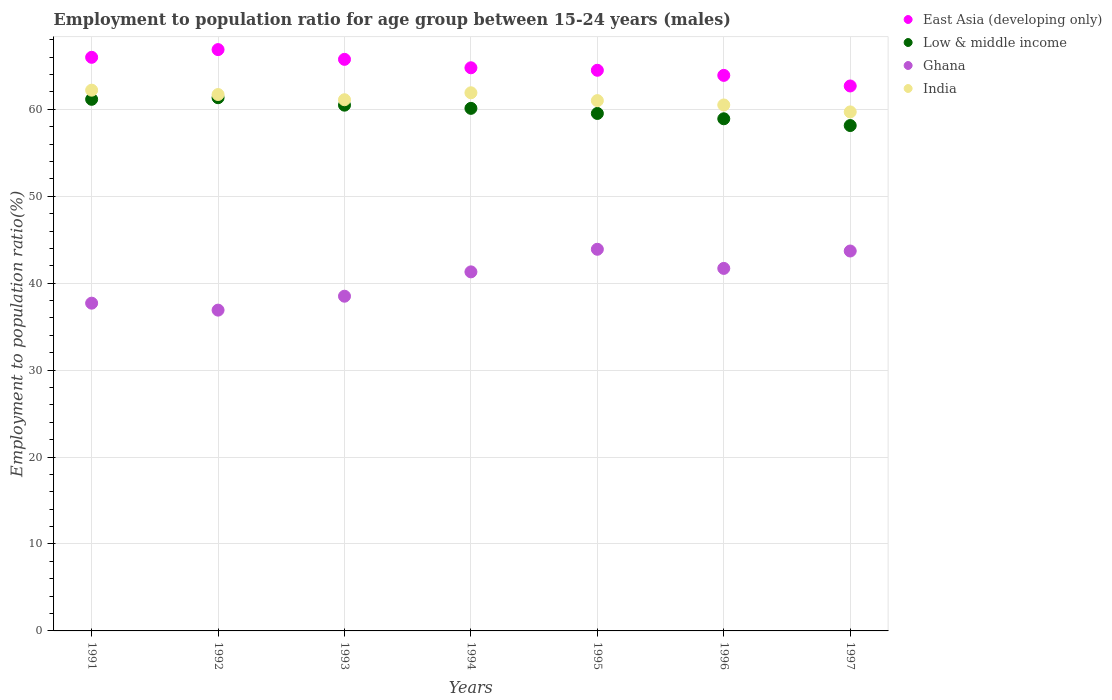Is the number of dotlines equal to the number of legend labels?
Offer a terse response. Yes. What is the employment to population ratio in Low & middle income in 1994?
Provide a short and direct response. 60.11. Across all years, what is the maximum employment to population ratio in Ghana?
Give a very brief answer. 43.9. Across all years, what is the minimum employment to population ratio in Ghana?
Give a very brief answer. 36.9. What is the total employment to population ratio in India in the graph?
Give a very brief answer. 428.1. What is the difference between the employment to population ratio in India in 1992 and that in 1995?
Provide a short and direct response. 0.7. What is the difference between the employment to population ratio in Low & middle income in 1992 and the employment to population ratio in East Asia (developing only) in 1994?
Give a very brief answer. -3.44. What is the average employment to population ratio in East Asia (developing only) per year?
Your response must be concise. 64.92. In the year 1992, what is the difference between the employment to population ratio in Low & middle income and employment to population ratio in Ghana?
Keep it short and to the point. 24.43. What is the ratio of the employment to population ratio in Ghana in 1991 to that in 1996?
Offer a very short reply. 0.9. Is the difference between the employment to population ratio in Low & middle income in 1996 and 1997 greater than the difference between the employment to population ratio in Ghana in 1996 and 1997?
Your answer should be very brief. Yes. What is the difference between the highest and the second highest employment to population ratio in Low & middle income?
Offer a terse response. 0.18. In how many years, is the employment to population ratio in India greater than the average employment to population ratio in India taken over all years?
Provide a succinct answer. 3. Is the sum of the employment to population ratio in Low & middle income in 1995 and 1997 greater than the maximum employment to population ratio in India across all years?
Your answer should be compact. Yes. Is it the case that in every year, the sum of the employment to population ratio in India and employment to population ratio in Ghana  is greater than the sum of employment to population ratio in Low & middle income and employment to population ratio in East Asia (developing only)?
Ensure brevity in your answer.  Yes. Does the employment to population ratio in Low & middle income monotonically increase over the years?
Your response must be concise. No. Is the employment to population ratio in Ghana strictly greater than the employment to population ratio in India over the years?
Your answer should be very brief. No. How many dotlines are there?
Keep it short and to the point. 4. Are the values on the major ticks of Y-axis written in scientific E-notation?
Keep it short and to the point. No. Where does the legend appear in the graph?
Give a very brief answer. Top right. How are the legend labels stacked?
Your response must be concise. Vertical. What is the title of the graph?
Keep it short and to the point. Employment to population ratio for age group between 15-24 years (males). What is the label or title of the X-axis?
Your answer should be compact. Years. What is the Employment to population ratio(%) of East Asia (developing only) in 1991?
Offer a terse response. 65.98. What is the Employment to population ratio(%) of Low & middle income in 1991?
Keep it short and to the point. 61.15. What is the Employment to population ratio(%) in Ghana in 1991?
Keep it short and to the point. 37.7. What is the Employment to population ratio(%) of India in 1991?
Provide a succinct answer. 62.2. What is the Employment to population ratio(%) in East Asia (developing only) in 1992?
Provide a short and direct response. 66.87. What is the Employment to population ratio(%) in Low & middle income in 1992?
Your answer should be compact. 61.33. What is the Employment to population ratio(%) of Ghana in 1992?
Ensure brevity in your answer.  36.9. What is the Employment to population ratio(%) of India in 1992?
Offer a terse response. 61.7. What is the Employment to population ratio(%) of East Asia (developing only) in 1993?
Your answer should be very brief. 65.75. What is the Employment to population ratio(%) of Low & middle income in 1993?
Offer a terse response. 60.48. What is the Employment to population ratio(%) of Ghana in 1993?
Your answer should be very brief. 38.5. What is the Employment to population ratio(%) of India in 1993?
Your response must be concise. 61.1. What is the Employment to population ratio(%) of East Asia (developing only) in 1994?
Make the answer very short. 64.78. What is the Employment to population ratio(%) in Low & middle income in 1994?
Offer a terse response. 60.11. What is the Employment to population ratio(%) of Ghana in 1994?
Your response must be concise. 41.3. What is the Employment to population ratio(%) of India in 1994?
Your response must be concise. 61.9. What is the Employment to population ratio(%) of East Asia (developing only) in 1995?
Make the answer very short. 64.49. What is the Employment to population ratio(%) of Low & middle income in 1995?
Provide a short and direct response. 59.52. What is the Employment to population ratio(%) of Ghana in 1995?
Provide a succinct answer. 43.9. What is the Employment to population ratio(%) in India in 1995?
Give a very brief answer. 61. What is the Employment to population ratio(%) in East Asia (developing only) in 1996?
Provide a short and direct response. 63.9. What is the Employment to population ratio(%) in Low & middle income in 1996?
Your answer should be compact. 58.91. What is the Employment to population ratio(%) of Ghana in 1996?
Provide a succinct answer. 41.7. What is the Employment to population ratio(%) in India in 1996?
Your response must be concise. 60.5. What is the Employment to population ratio(%) of East Asia (developing only) in 1997?
Keep it short and to the point. 62.68. What is the Employment to population ratio(%) in Low & middle income in 1997?
Your answer should be very brief. 58.13. What is the Employment to population ratio(%) in Ghana in 1997?
Keep it short and to the point. 43.7. What is the Employment to population ratio(%) of India in 1997?
Your response must be concise. 59.7. Across all years, what is the maximum Employment to population ratio(%) in East Asia (developing only)?
Provide a short and direct response. 66.87. Across all years, what is the maximum Employment to population ratio(%) of Low & middle income?
Offer a very short reply. 61.33. Across all years, what is the maximum Employment to population ratio(%) in Ghana?
Give a very brief answer. 43.9. Across all years, what is the maximum Employment to population ratio(%) of India?
Your answer should be compact. 62.2. Across all years, what is the minimum Employment to population ratio(%) in East Asia (developing only)?
Ensure brevity in your answer.  62.68. Across all years, what is the minimum Employment to population ratio(%) in Low & middle income?
Offer a very short reply. 58.13. Across all years, what is the minimum Employment to population ratio(%) of Ghana?
Provide a short and direct response. 36.9. Across all years, what is the minimum Employment to population ratio(%) of India?
Provide a short and direct response. 59.7. What is the total Employment to population ratio(%) of East Asia (developing only) in the graph?
Provide a short and direct response. 454.44. What is the total Employment to population ratio(%) of Low & middle income in the graph?
Provide a succinct answer. 419.63. What is the total Employment to population ratio(%) in Ghana in the graph?
Make the answer very short. 283.7. What is the total Employment to population ratio(%) in India in the graph?
Your answer should be compact. 428.1. What is the difference between the Employment to population ratio(%) of East Asia (developing only) in 1991 and that in 1992?
Offer a terse response. -0.89. What is the difference between the Employment to population ratio(%) of Low & middle income in 1991 and that in 1992?
Offer a terse response. -0.18. What is the difference between the Employment to population ratio(%) of Ghana in 1991 and that in 1992?
Give a very brief answer. 0.8. What is the difference between the Employment to population ratio(%) in East Asia (developing only) in 1991 and that in 1993?
Ensure brevity in your answer.  0.23. What is the difference between the Employment to population ratio(%) in Low & middle income in 1991 and that in 1993?
Make the answer very short. 0.67. What is the difference between the Employment to population ratio(%) of Ghana in 1991 and that in 1993?
Your response must be concise. -0.8. What is the difference between the Employment to population ratio(%) in East Asia (developing only) in 1991 and that in 1994?
Your answer should be compact. 1.2. What is the difference between the Employment to population ratio(%) in Low & middle income in 1991 and that in 1994?
Offer a terse response. 1.04. What is the difference between the Employment to population ratio(%) of East Asia (developing only) in 1991 and that in 1995?
Your response must be concise. 1.49. What is the difference between the Employment to population ratio(%) of Low & middle income in 1991 and that in 1995?
Your answer should be very brief. 1.63. What is the difference between the Employment to population ratio(%) of Ghana in 1991 and that in 1995?
Give a very brief answer. -6.2. What is the difference between the Employment to population ratio(%) in East Asia (developing only) in 1991 and that in 1996?
Give a very brief answer. 2.08. What is the difference between the Employment to population ratio(%) in Low & middle income in 1991 and that in 1996?
Offer a very short reply. 2.24. What is the difference between the Employment to population ratio(%) in East Asia (developing only) in 1991 and that in 1997?
Your answer should be very brief. 3.3. What is the difference between the Employment to population ratio(%) of Low & middle income in 1991 and that in 1997?
Your answer should be compact. 3.02. What is the difference between the Employment to population ratio(%) of Ghana in 1991 and that in 1997?
Offer a terse response. -6. What is the difference between the Employment to population ratio(%) of East Asia (developing only) in 1992 and that in 1993?
Give a very brief answer. 1.12. What is the difference between the Employment to population ratio(%) of Low & middle income in 1992 and that in 1993?
Offer a very short reply. 0.86. What is the difference between the Employment to population ratio(%) of Ghana in 1992 and that in 1993?
Make the answer very short. -1.6. What is the difference between the Employment to population ratio(%) of East Asia (developing only) in 1992 and that in 1994?
Your answer should be compact. 2.09. What is the difference between the Employment to population ratio(%) of Low & middle income in 1992 and that in 1994?
Offer a very short reply. 1.22. What is the difference between the Employment to population ratio(%) in India in 1992 and that in 1994?
Keep it short and to the point. -0.2. What is the difference between the Employment to population ratio(%) in East Asia (developing only) in 1992 and that in 1995?
Make the answer very short. 2.38. What is the difference between the Employment to population ratio(%) of Low & middle income in 1992 and that in 1995?
Your answer should be very brief. 1.81. What is the difference between the Employment to population ratio(%) of Ghana in 1992 and that in 1995?
Make the answer very short. -7. What is the difference between the Employment to population ratio(%) of East Asia (developing only) in 1992 and that in 1996?
Give a very brief answer. 2.97. What is the difference between the Employment to population ratio(%) in Low & middle income in 1992 and that in 1996?
Provide a short and direct response. 2.42. What is the difference between the Employment to population ratio(%) of Ghana in 1992 and that in 1996?
Provide a short and direct response. -4.8. What is the difference between the Employment to population ratio(%) in East Asia (developing only) in 1992 and that in 1997?
Your response must be concise. 4.18. What is the difference between the Employment to population ratio(%) of Low & middle income in 1992 and that in 1997?
Offer a terse response. 3.2. What is the difference between the Employment to population ratio(%) in Ghana in 1992 and that in 1997?
Provide a succinct answer. -6.8. What is the difference between the Employment to population ratio(%) of India in 1992 and that in 1997?
Provide a succinct answer. 2. What is the difference between the Employment to population ratio(%) of East Asia (developing only) in 1993 and that in 1994?
Ensure brevity in your answer.  0.97. What is the difference between the Employment to population ratio(%) in Low & middle income in 1993 and that in 1994?
Your answer should be compact. 0.37. What is the difference between the Employment to population ratio(%) of Ghana in 1993 and that in 1994?
Keep it short and to the point. -2.8. What is the difference between the Employment to population ratio(%) of East Asia (developing only) in 1993 and that in 1995?
Keep it short and to the point. 1.26. What is the difference between the Employment to population ratio(%) in Low & middle income in 1993 and that in 1995?
Your answer should be very brief. 0.95. What is the difference between the Employment to population ratio(%) of East Asia (developing only) in 1993 and that in 1996?
Offer a terse response. 1.84. What is the difference between the Employment to population ratio(%) of Low & middle income in 1993 and that in 1996?
Provide a succinct answer. 1.56. What is the difference between the Employment to population ratio(%) of Ghana in 1993 and that in 1996?
Keep it short and to the point. -3.2. What is the difference between the Employment to population ratio(%) in East Asia (developing only) in 1993 and that in 1997?
Provide a short and direct response. 3.06. What is the difference between the Employment to population ratio(%) in Low & middle income in 1993 and that in 1997?
Your response must be concise. 2.34. What is the difference between the Employment to population ratio(%) in Ghana in 1993 and that in 1997?
Ensure brevity in your answer.  -5.2. What is the difference between the Employment to population ratio(%) of East Asia (developing only) in 1994 and that in 1995?
Your response must be concise. 0.29. What is the difference between the Employment to population ratio(%) of Low & middle income in 1994 and that in 1995?
Your answer should be compact. 0.59. What is the difference between the Employment to population ratio(%) of Ghana in 1994 and that in 1995?
Give a very brief answer. -2.6. What is the difference between the Employment to population ratio(%) of India in 1994 and that in 1995?
Your answer should be compact. 0.9. What is the difference between the Employment to population ratio(%) of East Asia (developing only) in 1994 and that in 1996?
Your answer should be compact. 0.87. What is the difference between the Employment to population ratio(%) of Low & middle income in 1994 and that in 1996?
Keep it short and to the point. 1.2. What is the difference between the Employment to population ratio(%) of Ghana in 1994 and that in 1996?
Ensure brevity in your answer.  -0.4. What is the difference between the Employment to population ratio(%) in East Asia (developing only) in 1994 and that in 1997?
Your answer should be compact. 2.09. What is the difference between the Employment to population ratio(%) in Low & middle income in 1994 and that in 1997?
Your answer should be compact. 1.98. What is the difference between the Employment to population ratio(%) in Ghana in 1994 and that in 1997?
Your answer should be compact. -2.4. What is the difference between the Employment to population ratio(%) in India in 1994 and that in 1997?
Keep it short and to the point. 2.2. What is the difference between the Employment to population ratio(%) in East Asia (developing only) in 1995 and that in 1996?
Your answer should be very brief. 0.59. What is the difference between the Employment to population ratio(%) in Low & middle income in 1995 and that in 1996?
Your answer should be very brief. 0.61. What is the difference between the Employment to population ratio(%) in India in 1995 and that in 1996?
Offer a very short reply. 0.5. What is the difference between the Employment to population ratio(%) in East Asia (developing only) in 1995 and that in 1997?
Your answer should be compact. 1.81. What is the difference between the Employment to population ratio(%) of Low & middle income in 1995 and that in 1997?
Your answer should be compact. 1.39. What is the difference between the Employment to population ratio(%) of Ghana in 1995 and that in 1997?
Keep it short and to the point. 0.2. What is the difference between the Employment to population ratio(%) of East Asia (developing only) in 1996 and that in 1997?
Offer a terse response. 1.22. What is the difference between the Employment to population ratio(%) in Low & middle income in 1996 and that in 1997?
Your answer should be very brief. 0.78. What is the difference between the Employment to population ratio(%) in Ghana in 1996 and that in 1997?
Offer a terse response. -2. What is the difference between the Employment to population ratio(%) of East Asia (developing only) in 1991 and the Employment to population ratio(%) of Low & middle income in 1992?
Provide a short and direct response. 4.65. What is the difference between the Employment to population ratio(%) of East Asia (developing only) in 1991 and the Employment to population ratio(%) of Ghana in 1992?
Your response must be concise. 29.08. What is the difference between the Employment to population ratio(%) in East Asia (developing only) in 1991 and the Employment to population ratio(%) in India in 1992?
Your answer should be compact. 4.28. What is the difference between the Employment to population ratio(%) of Low & middle income in 1991 and the Employment to population ratio(%) of Ghana in 1992?
Your answer should be very brief. 24.25. What is the difference between the Employment to population ratio(%) in Low & middle income in 1991 and the Employment to population ratio(%) in India in 1992?
Make the answer very short. -0.55. What is the difference between the Employment to population ratio(%) of East Asia (developing only) in 1991 and the Employment to population ratio(%) of Low & middle income in 1993?
Your response must be concise. 5.5. What is the difference between the Employment to population ratio(%) of East Asia (developing only) in 1991 and the Employment to population ratio(%) of Ghana in 1993?
Provide a short and direct response. 27.48. What is the difference between the Employment to population ratio(%) of East Asia (developing only) in 1991 and the Employment to population ratio(%) of India in 1993?
Ensure brevity in your answer.  4.88. What is the difference between the Employment to population ratio(%) in Low & middle income in 1991 and the Employment to population ratio(%) in Ghana in 1993?
Provide a short and direct response. 22.65. What is the difference between the Employment to population ratio(%) of Low & middle income in 1991 and the Employment to population ratio(%) of India in 1993?
Your answer should be compact. 0.05. What is the difference between the Employment to population ratio(%) of Ghana in 1991 and the Employment to population ratio(%) of India in 1993?
Offer a terse response. -23.4. What is the difference between the Employment to population ratio(%) of East Asia (developing only) in 1991 and the Employment to population ratio(%) of Low & middle income in 1994?
Provide a succinct answer. 5.87. What is the difference between the Employment to population ratio(%) in East Asia (developing only) in 1991 and the Employment to population ratio(%) in Ghana in 1994?
Provide a short and direct response. 24.68. What is the difference between the Employment to population ratio(%) of East Asia (developing only) in 1991 and the Employment to population ratio(%) of India in 1994?
Keep it short and to the point. 4.08. What is the difference between the Employment to population ratio(%) in Low & middle income in 1991 and the Employment to population ratio(%) in Ghana in 1994?
Your answer should be compact. 19.85. What is the difference between the Employment to population ratio(%) of Low & middle income in 1991 and the Employment to population ratio(%) of India in 1994?
Your response must be concise. -0.75. What is the difference between the Employment to population ratio(%) in Ghana in 1991 and the Employment to population ratio(%) in India in 1994?
Provide a short and direct response. -24.2. What is the difference between the Employment to population ratio(%) in East Asia (developing only) in 1991 and the Employment to population ratio(%) in Low & middle income in 1995?
Your answer should be very brief. 6.46. What is the difference between the Employment to population ratio(%) of East Asia (developing only) in 1991 and the Employment to population ratio(%) of Ghana in 1995?
Your answer should be very brief. 22.08. What is the difference between the Employment to population ratio(%) in East Asia (developing only) in 1991 and the Employment to population ratio(%) in India in 1995?
Provide a short and direct response. 4.98. What is the difference between the Employment to population ratio(%) in Low & middle income in 1991 and the Employment to population ratio(%) in Ghana in 1995?
Your response must be concise. 17.25. What is the difference between the Employment to population ratio(%) in Low & middle income in 1991 and the Employment to population ratio(%) in India in 1995?
Offer a terse response. 0.15. What is the difference between the Employment to population ratio(%) of Ghana in 1991 and the Employment to population ratio(%) of India in 1995?
Provide a short and direct response. -23.3. What is the difference between the Employment to population ratio(%) of East Asia (developing only) in 1991 and the Employment to population ratio(%) of Low & middle income in 1996?
Your response must be concise. 7.07. What is the difference between the Employment to population ratio(%) of East Asia (developing only) in 1991 and the Employment to population ratio(%) of Ghana in 1996?
Your answer should be compact. 24.28. What is the difference between the Employment to population ratio(%) of East Asia (developing only) in 1991 and the Employment to population ratio(%) of India in 1996?
Your response must be concise. 5.48. What is the difference between the Employment to population ratio(%) of Low & middle income in 1991 and the Employment to population ratio(%) of Ghana in 1996?
Ensure brevity in your answer.  19.45. What is the difference between the Employment to population ratio(%) in Low & middle income in 1991 and the Employment to population ratio(%) in India in 1996?
Offer a terse response. 0.65. What is the difference between the Employment to population ratio(%) of Ghana in 1991 and the Employment to population ratio(%) of India in 1996?
Ensure brevity in your answer.  -22.8. What is the difference between the Employment to population ratio(%) of East Asia (developing only) in 1991 and the Employment to population ratio(%) of Low & middle income in 1997?
Offer a terse response. 7.85. What is the difference between the Employment to population ratio(%) of East Asia (developing only) in 1991 and the Employment to population ratio(%) of Ghana in 1997?
Provide a short and direct response. 22.28. What is the difference between the Employment to population ratio(%) of East Asia (developing only) in 1991 and the Employment to population ratio(%) of India in 1997?
Ensure brevity in your answer.  6.28. What is the difference between the Employment to population ratio(%) in Low & middle income in 1991 and the Employment to population ratio(%) in Ghana in 1997?
Your answer should be compact. 17.45. What is the difference between the Employment to population ratio(%) in Low & middle income in 1991 and the Employment to population ratio(%) in India in 1997?
Your answer should be compact. 1.45. What is the difference between the Employment to population ratio(%) of Ghana in 1991 and the Employment to population ratio(%) of India in 1997?
Your answer should be compact. -22. What is the difference between the Employment to population ratio(%) of East Asia (developing only) in 1992 and the Employment to population ratio(%) of Low & middle income in 1993?
Make the answer very short. 6.39. What is the difference between the Employment to population ratio(%) in East Asia (developing only) in 1992 and the Employment to population ratio(%) in Ghana in 1993?
Keep it short and to the point. 28.37. What is the difference between the Employment to population ratio(%) in East Asia (developing only) in 1992 and the Employment to population ratio(%) in India in 1993?
Provide a short and direct response. 5.77. What is the difference between the Employment to population ratio(%) of Low & middle income in 1992 and the Employment to population ratio(%) of Ghana in 1993?
Your answer should be very brief. 22.83. What is the difference between the Employment to population ratio(%) in Low & middle income in 1992 and the Employment to population ratio(%) in India in 1993?
Offer a terse response. 0.23. What is the difference between the Employment to population ratio(%) in Ghana in 1992 and the Employment to population ratio(%) in India in 1993?
Keep it short and to the point. -24.2. What is the difference between the Employment to population ratio(%) in East Asia (developing only) in 1992 and the Employment to population ratio(%) in Low & middle income in 1994?
Ensure brevity in your answer.  6.76. What is the difference between the Employment to population ratio(%) in East Asia (developing only) in 1992 and the Employment to population ratio(%) in Ghana in 1994?
Provide a succinct answer. 25.57. What is the difference between the Employment to population ratio(%) of East Asia (developing only) in 1992 and the Employment to population ratio(%) of India in 1994?
Offer a terse response. 4.97. What is the difference between the Employment to population ratio(%) of Low & middle income in 1992 and the Employment to population ratio(%) of Ghana in 1994?
Ensure brevity in your answer.  20.03. What is the difference between the Employment to population ratio(%) of Low & middle income in 1992 and the Employment to population ratio(%) of India in 1994?
Offer a very short reply. -0.57. What is the difference between the Employment to population ratio(%) of East Asia (developing only) in 1992 and the Employment to population ratio(%) of Low & middle income in 1995?
Provide a succinct answer. 7.34. What is the difference between the Employment to population ratio(%) of East Asia (developing only) in 1992 and the Employment to population ratio(%) of Ghana in 1995?
Your answer should be compact. 22.97. What is the difference between the Employment to population ratio(%) in East Asia (developing only) in 1992 and the Employment to population ratio(%) in India in 1995?
Ensure brevity in your answer.  5.87. What is the difference between the Employment to population ratio(%) of Low & middle income in 1992 and the Employment to population ratio(%) of Ghana in 1995?
Keep it short and to the point. 17.43. What is the difference between the Employment to population ratio(%) in Low & middle income in 1992 and the Employment to population ratio(%) in India in 1995?
Your response must be concise. 0.33. What is the difference between the Employment to population ratio(%) in Ghana in 1992 and the Employment to population ratio(%) in India in 1995?
Keep it short and to the point. -24.1. What is the difference between the Employment to population ratio(%) in East Asia (developing only) in 1992 and the Employment to population ratio(%) in Low & middle income in 1996?
Keep it short and to the point. 7.96. What is the difference between the Employment to population ratio(%) in East Asia (developing only) in 1992 and the Employment to population ratio(%) in Ghana in 1996?
Make the answer very short. 25.17. What is the difference between the Employment to population ratio(%) in East Asia (developing only) in 1992 and the Employment to population ratio(%) in India in 1996?
Ensure brevity in your answer.  6.37. What is the difference between the Employment to population ratio(%) in Low & middle income in 1992 and the Employment to population ratio(%) in Ghana in 1996?
Your answer should be very brief. 19.63. What is the difference between the Employment to population ratio(%) in Low & middle income in 1992 and the Employment to population ratio(%) in India in 1996?
Your answer should be very brief. 0.83. What is the difference between the Employment to population ratio(%) in Ghana in 1992 and the Employment to population ratio(%) in India in 1996?
Offer a very short reply. -23.6. What is the difference between the Employment to population ratio(%) in East Asia (developing only) in 1992 and the Employment to population ratio(%) in Low & middle income in 1997?
Offer a very short reply. 8.74. What is the difference between the Employment to population ratio(%) of East Asia (developing only) in 1992 and the Employment to population ratio(%) of Ghana in 1997?
Ensure brevity in your answer.  23.17. What is the difference between the Employment to population ratio(%) of East Asia (developing only) in 1992 and the Employment to population ratio(%) of India in 1997?
Your answer should be very brief. 7.17. What is the difference between the Employment to population ratio(%) in Low & middle income in 1992 and the Employment to population ratio(%) in Ghana in 1997?
Make the answer very short. 17.63. What is the difference between the Employment to population ratio(%) of Low & middle income in 1992 and the Employment to population ratio(%) of India in 1997?
Give a very brief answer. 1.63. What is the difference between the Employment to population ratio(%) in Ghana in 1992 and the Employment to population ratio(%) in India in 1997?
Your answer should be compact. -22.8. What is the difference between the Employment to population ratio(%) of East Asia (developing only) in 1993 and the Employment to population ratio(%) of Low & middle income in 1994?
Offer a terse response. 5.64. What is the difference between the Employment to population ratio(%) in East Asia (developing only) in 1993 and the Employment to population ratio(%) in Ghana in 1994?
Your response must be concise. 24.45. What is the difference between the Employment to population ratio(%) of East Asia (developing only) in 1993 and the Employment to population ratio(%) of India in 1994?
Give a very brief answer. 3.85. What is the difference between the Employment to population ratio(%) of Low & middle income in 1993 and the Employment to population ratio(%) of Ghana in 1994?
Make the answer very short. 19.18. What is the difference between the Employment to population ratio(%) of Low & middle income in 1993 and the Employment to population ratio(%) of India in 1994?
Provide a short and direct response. -1.42. What is the difference between the Employment to population ratio(%) of Ghana in 1993 and the Employment to population ratio(%) of India in 1994?
Your response must be concise. -23.4. What is the difference between the Employment to population ratio(%) of East Asia (developing only) in 1993 and the Employment to population ratio(%) of Low & middle income in 1995?
Keep it short and to the point. 6.22. What is the difference between the Employment to population ratio(%) in East Asia (developing only) in 1993 and the Employment to population ratio(%) in Ghana in 1995?
Provide a succinct answer. 21.85. What is the difference between the Employment to population ratio(%) in East Asia (developing only) in 1993 and the Employment to population ratio(%) in India in 1995?
Offer a very short reply. 4.75. What is the difference between the Employment to population ratio(%) of Low & middle income in 1993 and the Employment to population ratio(%) of Ghana in 1995?
Make the answer very short. 16.58. What is the difference between the Employment to population ratio(%) of Low & middle income in 1993 and the Employment to population ratio(%) of India in 1995?
Offer a very short reply. -0.52. What is the difference between the Employment to population ratio(%) of Ghana in 1993 and the Employment to population ratio(%) of India in 1995?
Provide a short and direct response. -22.5. What is the difference between the Employment to population ratio(%) of East Asia (developing only) in 1993 and the Employment to population ratio(%) of Low & middle income in 1996?
Provide a short and direct response. 6.84. What is the difference between the Employment to population ratio(%) of East Asia (developing only) in 1993 and the Employment to population ratio(%) of Ghana in 1996?
Your answer should be very brief. 24.05. What is the difference between the Employment to population ratio(%) of East Asia (developing only) in 1993 and the Employment to population ratio(%) of India in 1996?
Give a very brief answer. 5.25. What is the difference between the Employment to population ratio(%) in Low & middle income in 1993 and the Employment to population ratio(%) in Ghana in 1996?
Keep it short and to the point. 18.78. What is the difference between the Employment to population ratio(%) of Low & middle income in 1993 and the Employment to population ratio(%) of India in 1996?
Offer a very short reply. -0.02. What is the difference between the Employment to population ratio(%) in Ghana in 1993 and the Employment to population ratio(%) in India in 1996?
Provide a succinct answer. -22. What is the difference between the Employment to population ratio(%) of East Asia (developing only) in 1993 and the Employment to population ratio(%) of Low & middle income in 1997?
Provide a short and direct response. 7.61. What is the difference between the Employment to population ratio(%) in East Asia (developing only) in 1993 and the Employment to population ratio(%) in Ghana in 1997?
Make the answer very short. 22.05. What is the difference between the Employment to population ratio(%) of East Asia (developing only) in 1993 and the Employment to population ratio(%) of India in 1997?
Ensure brevity in your answer.  6.05. What is the difference between the Employment to population ratio(%) in Low & middle income in 1993 and the Employment to population ratio(%) in Ghana in 1997?
Make the answer very short. 16.78. What is the difference between the Employment to population ratio(%) in Low & middle income in 1993 and the Employment to population ratio(%) in India in 1997?
Your response must be concise. 0.78. What is the difference between the Employment to population ratio(%) of Ghana in 1993 and the Employment to population ratio(%) of India in 1997?
Ensure brevity in your answer.  -21.2. What is the difference between the Employment to population ratio(%) of East Asia (developing only) in 1994 and the Employment to population ratio(%) of Low & middle income in 1995?
Provide a succinct answer. 5.25. What is the difference between the Employment to population ratio(%) of East Asia (developing only) in 1994 and the Employment to population ratio(%) of Ghana in 1995?
Make the answer very short. 20.88. What is the difference between the Employment to population ratio(%) in East Asia (developing only) in 1994 and the Employment to population ratio(%) in India in 1995?
Make the answer very short. 3.78. What is the difference between the Employment to population ratio(%) of Low & middle income in 1994 and the Employment to population ratio(%) of Ghana in 1995?
Your answer should be very brief. 16.21. What is the difference between the Employment to population ratio(%) of Low & middle income in 1994 and the Employment to population ratio(%) of India in 1995?
Your answer should be compact. -0.89. What is the difference between the Employment to population ratio(%) in Ghana in 1994 and the Employment to population ratio(%) in India in 1995?
Offer a very short reply. -19.7. What is the difference between the Employment to population ratio(%) of East Asia (developing only) in 1994 and the Employment to population ratio(%) of Low & middle income in 1996?
Ensure brevity in your answer.  5.87. What is the difference between the Employment to population ratio(%) of East Asia (developing only) in 1994 and the Employment to population ratio(%) of Ghana in 1996?
Offer a very short reply. 23.08. What is the difference between the Employment to population ratio(%) in East Asia (developing only) in 1994 and the Employment to population ratio(%) in India in 1996?
Ensure brevity in your answer.  4.28. What is the difference between the Employment to population ratio(%) in Low & middle income in 1994 and the Employment to population ratio(%) in Ghana in 1996?
Your response must be concise. 18.41. What is the difference between the Employment to population ratio(%) of Low & middle income in 1994 and the Employment to population ratio(%) of India in 1996?
Offer a terse response. -0.39. What is the difference between the Employment to population ratio(%) in Ghana in 1994 and the Employment to population ratio(%) in India in 1996?
Give a very brief answer. -19.2. What is the difference between the Employment to population ratio(%) in East Asia (developing only) in 1994 and the Employment to population ratio(%) in Low & middle income in 1997?
Ensure brevity in your answer.  6.64. What is the difference between the Employment to population ratio(%) of East Asia (developing only) in 1994 and the Employment to population ratio(%) of Ghana in 1997?
Provide a succinct answer. 21.08. What is the difference between the Employment to population ratio(%) of East Asia (developing only) in 1994 and the Employment to population ratio(%) of India in 1997?
Your answer should be very brief. 5.08. What is the difference between the Employment to population ratio(%) of Low & middle income in 1994 and the Employment to population ratio(%) of Ghana in 1997?
Your answer should be compact. 16.41. What is the difference between the Employment to population ratio(%) of Low & middle income in 1994 and the Employment to population ratio(%) of India in 1997?
Provide a succinct answer. 0.41. What is the difference between the Employment to population ratio(%) of Ghana in 1994 and the Employment to population ratio(%) of India in 1997?
Your response must be concise. -18.4. What is the difference between the Employment to population ratio(%) in East Asia (developing only) in 1995 and the Employment to population ratio(%) in Low & middle income in 1996?
Your answer should be compact. 5.58. What is the difference between the Employment to population ratio(%) of East Asia (developing only) in 1995 and the Employment to population ratio(%) of Ghana in 1996?
Ensure brevity in your answer.  22.79. What is the difference between the Employment to population ratio(%) of East Asia (developing only) in 1995 and the Employment to population ratio(%) of India in 1996?
Offer a terse response. 3.99. What is the difference between the Employment to population ratio(%) in Low & middle income in 1995 and the Employment to population ratio(%) in Ghana in 1996?
Make the answer very short. 17.82. What is the difference between the Employment to population ratio(%) in Low & middle income in 1995 and the Employment to population ratio(%) in India in 1996?
Your answer should be very brief. -0.98. What is the difference between the Employment to population ratio(%) in Ghana in 1995 and the Employment to population ratio(%) in India in 1996?
Provide a succinct answer. -16.6. What is the difference between the Employment to population ratio(%) in East Asia (developing only) in 1995 and the Employment to population ratio(%) in Low & middle income in 1997?
Provide a short and direct response. 6.36. What is the difference between the Employment to population ratio(%) of East Asia (developing only) in 1995 and the Employment to population ratio(%) of Ghana in 1997?
Offer a terse response. 20.79. What is the difference between the Employment to population ratio(%) of East Asia (developing only) in 1995 and the Employment to population ratio(%) of India in 1997?
Ensure brevity in your answer.  4.79. What is the difference between the Employment to population ratio(%) in Low & middle income in 1995 and the Employment to population ratio(%) in Ghana in 1997?
Provide a succinct answer. 15.82. What is the difference between the Employment to population ratio(%) in Low & middle income in 1995 and the Employment to population ratio(%) in India in 1997?
Your answer should be compact. -0.18. What is the difference between the Employment to population ratio(%) of Ghana in 1995 and the Employment to population ratio(%) of India in 1997?
Your answer should be very brief. -15.8. What is the difference between the Employment to population ratio(%) in East Asia (developing only) in 1996 and the Employment to population ratio(%) in Low & middle income in 1997?
Keep it short and to the point. 5.77. What is the difference between the Employment to population ratio(%) in East Asia (developing only) in 1996 and the Employment to population ratio(%) in Ghana in 1997?
Keep it short and to the point. 20.2. What is the difference between the Employment to population ratio(%) in East Asia (developing only) in 1996 and the Employment to population ratio(%) in India in 1997?
Provide a short and direct response. 4.2. What is the difference between the Employment to population ratio(%) in Low & middle income in 1996 and the Employment to population ratio(%) in Ghana in 1997?
Keep it short and to the point. 15.21. What is the difference between the Employment to population ratio(%) in Low & middle income in 1996 and the Employment to population ratio(%) in India in 1997?
Keep it short and to the point. -0.79. What is the average Employment to population ratio(%) in East Asia (developing only) per year?
Keep it short and to the point. 64.92. What is the average Employment to population ratio(%) in Low & middle income per year?
Your response must be concise. 59.95. What is the average Employment to population ratio(%) of Ghana per year?
Ensure brevity in your answer.  40.53. What is the average Employment to population ratio(%) in India per year?
Keep it short and to the point. 61.16. In the year 1991, what is the difference between the Employment to population ratio(%) in East Asia (developing only) and Employment to population ratio(%) in Low & middle income?
Provide a short and direct response. 4.83. In the year 1991, what is the difference between the Employment to population ratio(%) in East Asia (developing only) and Employment to population ratio(%) in Ghana?
Make the answer very short. 28.28. In the year 1991, what is the difference between the Employment to population ratio(%) in East Asia (developing only) and Employment to population ratio(%) in India?
Offer a very short reply. 3.78. In the year 1991, what is the difference between the Employment to population ratio(%) in Low & middle income and Employment to population ratio(%) in Ghana?
Offer a terse response. 23.45. In the year 1991, what is the difference between the Employment to population ratio(%) of Low & middle income and Employment to population ratio(%) of India?
Your answer should be compact. -1.05. In the year 1991, what is the difference between the Employment to population ratio(%) of Ghana and Employment to population ratio(%) of India?
Your answer should be very brief. -24.5. In the year 1992, what is the difference between the Employment to population ratio(%) in East Asia (developing only) and Employment to population ratio(%) in Low & middle income?
Offer a very short reply. 5.53. In the year 1992, what is the difference between the Employment to population ratio(%) in East Asia (developing only) and Employment to population ratio(%) in Ghana?
Ensure brevity in your answer.  29.97. In the year 1992, what is the difference between the Employment to population ratio(%) in East Asia (developing only) and Employment to population ratio(%) in India?
Give a very brief answer. 5.17. In the year 1992, what is the difference between the Employment to population ratio(%) in Low & middle income and Employment to population ratio(%) in Ghana?
Your answer should be compact. 24.43. In the year 1992, what is the difference between the Employment to population ratio(%) in Low & middle income and Employment to population ratio(%) in India?
Offer a very short reply. -0.37. In the year 1992, what is the difference between the Employment to population ratio(%) in Ghana and Employment to population ratio(%) in India?
Provide a succinct answer. -24.8. In the year 1993, what is the difference between the Employment to population ratio(%) in East Asia (developing only) and Employment to population ratio(%) in Low & middle income?
Offer a terse response. 5.27. In the year 1993, what is the difference between the Employment to population ratio(%) in East Asia (developing only) and Employment to population ratio(%) in Ghana?
Provide a short and direct response. 27.25. In the year 1993, what is the difference between the Employment to population ratio(%) of East Asia (developing only) and Employment to population ratio(%) of India?
Your response must be concise. 4.65. In the year 1993, what is the difference between the Employment to population ratio(%) of Low & middle income and Employment to population ratio(%) of Ghana?
Provide a succinct answer. 21.98. In the year 1993, what is the difference between the Employment to population ratio(%) in Low & middle income and Employment to population ratio(%) in India?
Your answer should be compact. -0.62. In the year 1993, what is the difference between the Employment to population ratio(%) of Ghana and Employment to population ratio(%) of India?
Make the answer very short. -22.6. In the year 1994, what is the difference between the Employment to population ratio(%) of East Asia (developing only) and Employment to population ratio(%) of Low & middle income?
Ensure brevity in your answer.  4.67. In the year 1994, what is the difference between the Employment to population ratio(%) of East Asia (developing only) and Employment to population ratio(%) of Ghana?
Your answer should be very brief. 23.48. In the year 1994, what is the difference between the Employment to population ratio(%) in East Asia (developing only) and Employment to population ratio(%) in India?
Offer a terse response. 2.88. In the year 1994, what is the difference between the Employment to population ratio(%) in Low & middle income and Employment to population ratio(%) in Ghana?
Your answer should be very brief. 18.81. In the year 1994, what is the difference between the Employment to population ratio(%) of Low & middle income and Employment to population ratio(%) of India?
Give a very brief answer. -1.79. In the year 1994, what is the difference between the Employment to population ratio(%) of Ghana and Employment to population ratio(%) of India?
Keep it short and to the point. -20.6. In the year 1995, what is the difference between the Employment to population ratio(%) of East Asia (developing only) and Employment to population ratio(%) of Low & middle income?
Offer a very short reply. 4.97. In the year 1995, what is the difference between the Employment to population ratio(%) of East Asia (developing only) and Employment to population ratio(%) of Ghana?
Give a very brief answer. 20.59. In the year 1995, what is the difference between the Employment to population ratio(%) of East Asia (developing only) and Employment to population ratio(%) of India?
Your answer should be compact. 3.49. In the year 1995, what is the difference between the Employment to population ratio(%) of Low & middle income and Employment to population ratio(%) of Ghana?
Give a very brief answer. 15.62. In the year 1995, what is the difference between the Employment to population ratio(%) of Low & middle income and Employment to population ratio(%) of India?
Give a very brief answer. -1.48. In the year 1995, what is the difference between the Employment to population ratio(%) of Ghana and Employment to population ratio(%) of India?
Ensure brevity in your answer.  -17.1. In the year 1996, what is the difference between the Employment to population ratio(%) of East Asia (developing only) and Employment to population ratio(%) of Low & middle income?
Your answer should be very brief. 4.99. In the year 1996, what is the difference between the Employment to population ratio(%) of East Asia (developing only) and Employment to population ratio(%) of Ghana?
Your answer should be compact. 22.2. In the year 1996, what is the difference between the Employment to population ratio(%) in East Asia (developing only) and Employment to population ratio(%) in India?
Give a very brief answer. 3.4. In the year 1996, what is the difference between the Employment to population ratio(%) in Low & middle income and Employment to population ratio(%) in Ghana?
Your answer should be compact. 17.21. In the year 1996, what is the difference between the Employment to population ratio(%) of Low & middle income and Employment to population ratio(%) of India?
Offer a very short reply. -1.59. In the year 1996, what is the difference between the Employment to population ratio(%) of Ghana and Employment to population ratio(%) of India?
Provide a succinct answer. -18.8. In the year 1997, what is the difference between the Employment to population ratio(%) of East Asia (developing only) and Employment to population ratio(%) of Low & middle income?
Your answer should be compact. 4.55. In the year 1997, what is the difference between the Employment to population ratio(%) in East Asia (developing only) and Employment to population ratio(%) in Ghana?
Keep it short and to the point. 18.98. In the year 1997, what is the difference between the Employment to population ratio(%) in East Asia (developing only) and Employment to population ratio(%) in India?
Offer a very short reply. 2.98. In the year 1997, what is the difference between the Employment to population ratio(%) of Low & middle income and Employment to population ratio(%) of Ghana?
Keep it short and to the point. 14.43. In the year 1997, what is the difference between the Employment to population ratio(%) of Low & middle income and Employment to population ratio(%) of India?
Offer a very short reply. -1.57. In the year 1997, what is the difference between the Employment to population ratio(%) of Ghana and Employment to population ratio(%) of India?
Offer a terse response. -16. What is the ratio of the Employment to population ratio(%) of East Asia (developing only) in 1991 to that in 1992?
Give a very brief answer. 0.99. What is the ratio of the Employment to population ratio(%) of Ghana in 1991 to that in 1992?
Offer a terse response. 1.02. What is the ratio of the Employment to population ratio(%) in India in 1991 to that in 1992?
Your answer should be very brief. 1.01. What is the ratio of the Employment to population ratio(%) of Low & middle income in 1991 to that in 1993?
Your answer should be very brief. 1.01. What is the ratio of the Employment to population ratio(%) in Ghana in 1991 to that in 1993?
Offer a terse response. 0.98. What is the ratio of the Employment to population ratio(%) of India in 1991 to that in 1993?
Provide a succinct answer. 1.02. What is the ratio of the Employment to population ratio(%) in East Asia (developing only) in 1991 to that in 1994?
Ensure brevity in your answer.  1.02. What is the ratio of the Employment to population ratio(%) of Low & middle income in 1991 to that in 1994?
Make the answer very short. 1.02. What is the ratio of the Employment to population ratio(%) in Ghana in 1991 to that in 1994?
Your answer should be compact. 0.91. What is the ratio of the Employment to population ratio(%) of India in 1991 to that in 1994?
Your answer should be very brief. 1. What is the ratio of the Employment to population ratio(%) in East Asia (developing only) in 1991 to that in 1995?
Your answer should be compact. 1.02. What is the ratio of the Employment to population ratio(%) in Low & middle income in 1991 to that in 1995?
Your answer should be compact. 1.03. What is the ratio of the Employment to population ratio(%) in Ghana in 1991 to that in 1995?
Offer a terse response. 0.86. What is the ratio of the Employment to population ratio(%) of India in 1991 to that in 1995?
Ensure brevity in your answer.  1.02. What is the ratio of the Employment to population ratio(%) in East Asia (developing only) in 1991 to that in 1996?
Make the answer very short. 1.03. What is the ratio of the Employment to population ratio(%) in Low & middle income in 1991 to that in 1996?
Ensure brevity in your answer.  1.04. What is the ratio of the Employment to population ratio(%) of Ghana in 1991 to that in 1996?
Make the answer very short. 0.9. What is the ratio of the Employment to population ratio(%) in India in 1991 to that in 1996?
Your answer should be very brief. 1.03. What is the ratio of the Employment to population ratio(%) in East Asia (developing only) in 1991 to that in 1997?
Keep it short and to the point. 1.05. What is the ratio of the Employment to population ratio(%) in Low & middle income in 1991 to that in 1997?
Keep it short and to the point. 1.05. What is the ratio of the Employment to population ratio(%) in Ghana in 1991 to that in 1997?
Give a very brief answer. 0.86. What is the ratio of the Employment to population ratio(%) of India in 1991 to that in 1997?
Your answer should be compact. 1.04. What is the ratio of the Employment to population ratio(%) in East Asia (developing only) in 1992 to that in 1993?
Provide a succinct answer. 1.02. What is the ratio of the Employment to population ratio(%) in Low & middle income in 1992 to that in 1993?
Keep it short and to the point. 1.01. What is the ratio of the Employment to population ratio(%) of Ghana in 1992 to that in 1993?
Offer a terse response. 0.96. What is the ratio of the Employment to population ratio(%) in India in 1992 to that in 1993?
Make the answer very short. 1.01. What is the ratio of the Employment to population ratio(%) of East Asia (developing only) in 1992 to that in 1994?
Give a very brief answer. 1.03. What is the ratio of the Employment to population ratio(%) of Low & middle income in 1992 to that in 1994?
Ensure brevity in your answer.  1.02. What is the ratio of the Employment to population ratio(%) of Ghana in 1992 to that in 1994?
Your answer should be very brief. 0.89. What is the ratio of the Employment to population ratio(%) of East Asia (developing only) in 1992 to that in 1995?
Provide a succinct answer. 1.04. What is the ratio of the Employment to population ratio(%) of Low & middle income in 1992 to that in 1995?
Offer a terse response. 1.03. What is the ratio of the Employment to population ratio(%) of Ghana in 1992 to that in 1995?
Give a very brief answer. 0.84. What is the ratio of the Employment to population ratio(%) in India in 1992 to that in 1995?
Make the answer very short. 1.01. What is the ratio of the Employment to population ratio(%) in East Asia (developing only) in 1992 to that in 1996?
Provide a short and direct response. 1.05. What is the ratio of the Employment to population ratio(%) in Low & middle income in 1992 to that in 1996?
Ensure brevity in your answer.  1.04. What is the ratio of the Employment to population ratio(%) of Ghana in 1992 to that in 1996?
Provide a short and direct response. 0.88. What is the ratio of the Employment to population ratio(%) in India in 1992 to that in 1996?
Provide a succinct answer. 1.02. What is the ratio of the Employment to population ratio(%) of East Asia (developing only) in 1992 to that in 1997?
Offer a terse response. 1.07. What is the ratio of the Employment to population ratio(%) of Low & middle income in 1992 to that in 1997?
Give a very brief answer. 1.06. What is the ratio of the Employment to population ratio(%) of Ghana in 1992 to that in 1997?
Keep it short and to the point. 0.84. What is the ratio of the Employment to population ratio(%) in India in 1992 to that in 1997?
Your answer should be very brief. 1.03. What is the ratio of the Employment to population ratio(%) of East Asia (developing only) in 1993 to that in 1994?
Give a very brief answer. 1.01. What is the ratio of the Employment to population ratio(%) of Low & middle income in 1993 to that in 1994?
Your answer should be compact. 1.01. What is the ratio of the Employment to population ratio(%) of Ghana in 1993 to that in 1994?
Ensure brevity in your answer.  0.93. What is the ratio of the Employment to population ratio(%) of India in 1993 to that in 1994?
Ensure brevity in your answer.  0.99. What is the ratio of the Employment to population ratio(%) of East Asia (developing only) in 1993 to that in 1995?
Keep it short and to the point. 1.02. What is the ratio of the Employment to population ratio(%) in Ghana in 1993 to that in 1995?
Provide a short and direct response. 0.88. What is the ratio of the Employment to population ratio(%) of East Asia (developing only) in 1993 to that in 1996?
Keep it short and to the point. 1.03. What is the ratio of the Employment to population ratio(%) of Low & middle income in 1993 to that in 1996?
Provide a succinct answer. 1.03. What is the ratio of the Employment to population ratio(%) in Ghana in 1993 to that in 1996?
Make the answer very short. 0.92. What is the ratio of the Employment to population ratio(%) of India in 1993 to that in 1996?
Your response must be concise. 1.01. What is the ratio of the Employment to population ratio(%) of East Asia (developing only) in 1993 to that in 1997?
Ensure brevity in your answer.  1.05. What is the ratio of the Employment to population ratio(%) in Low & middle income in 1993 to that in 1997?
Offer a terse response. 1.04. What is the ratio of the Employment to population ratio(%) in Ghana in 1993 to that in 1997?
Make the answer very short. 0.88. What is the ratio of the Employment to population ratio(%) of India in 1993 to that in 1997?
Give a very brief answer. 1.02. What is the ratio of the Employment to population ratio(%) of Low & middle income in 1994 to that in 1995?
Provide a succinct answer. 1.01. What is the ratio of the Employment to population ratio(%) of Ghana in 1994 to that in 1995?
Your answer should be very brief. 0.94. What is the ratio of the Employment to population ratio(%) of India in 1994 to that in 1995?
Make the answer very short. 1.01. What is the ratio of the Employment to population ratio(%) in East Asia (developing only) in 1994 to that in 1996?
Offer a terse response. 1.01. What is the ratio of the Employment to population ratio(%) in Low & middle income in 1994 to that in 1996?
Your response must be concise. 1.02. What is the ratio of the Employment to population ratio(%) of Ghana in 1994 to that in 1996?
Give a very brief answer. 0.99. What is the ratio of the Employment to population ratio(%) in India in 1994 to that in 1996?
Provide a short and direct response. 1.02. What is the ratio of the Employment to population ratio(%) of East Asia (developing only) in 1994 to that in 1997?
Offer a terse response. 1.03. What is the ratio of the Employment to population ratio(%) of Low & middle income in 1994 to that in 1997?
Your answer should be very brief. 1.03. What is the ratio of the Employment to population ratio(%) of Ghana in 1994 to that in 1997?
Keep it short and to the point. 0.95. What is the ratio of the Employment to population ratio(%) in India in 1994 to that in 1997?
Keep it short and to the point. 1.04. What is the ratio of the Employment to population ratio(%) in East Asia (developing only) in 1995 to that in 1996?
Offer a very short reply. 1.01. What is the ratio of the Employment to population ratio(%) of Low & middle income in 1995 to that in 1996?
Your answer should be compact. 1.01. What is the ratio of the Employment to population ratio(%) of Ghana in 1995 to that in 1996?
Make the answer very short. 1.05. What is the ratio of the Employment to population ratio(%) in India in 1995 to that in 1996?
Offer a terse response. 1.01. What is the ratio of the Employment to population ratio(%) of East Asia (developing only) in 1995 to that in 1997?
Ensure brevity in your answer.  1.03. What is the ratio of the Employment to population ratio(%) in Low & middle income in 1995 to that in 1997?
Offer a very short reply. 1.02. What is the ratio of the Employment to population ratio(%) of India in 1995 to that in 1997?
Your answer should be very brief. 1.02. What is the ratio of the Employment to population ratio(%) in East Asia (developing only) in 1996 to that in 1997?
Ensure brevity in your answer.  1.02. What is the ratio of the Employment to population ratio(%) in Low & middle income in 1996 to that in 1997?
Provide a succinct answer. 1.01. What is the ratio of the Employment to population ratio(%) in Ghana in 1996 to that in 1997?
Your answer should be very brief. 0.95. What is the ratio of the Employment to population ratio(%) of India in 1996 to that in 1997?
Provide a short and direct response. 1.01. What is the difference between the highest and the second highest Employment to population ratio(%) in East Asia (developing only)?
Provide a short and direct response. 0.89. What is the difference between the highest and the second highest Employment to population ratio(%) of Low & middle income?
Your answer should be compact. 0.18. What is the difference between the highest and the second highest Employment to population ratio(%) in Ghana?
Keep it short and to the point. 0.2. What is the difference between the highest and the lowest Employment to population ratio(%) in East Asia (developing only)?
Keep it short and to the point. 4.18. What is the difference between the highest and the lowest Employment to population ratio(%) in Low & middle income?
Provide a succinct answer. 3.2. What is the difference between the highest and the lowest Employment to population ratio(%) in Ghana?
Your answer should be very brief. 7. What is the difference between the highest and the lowest Employment to population ratio(%) of India?
Make the answer very short. 2.5. 